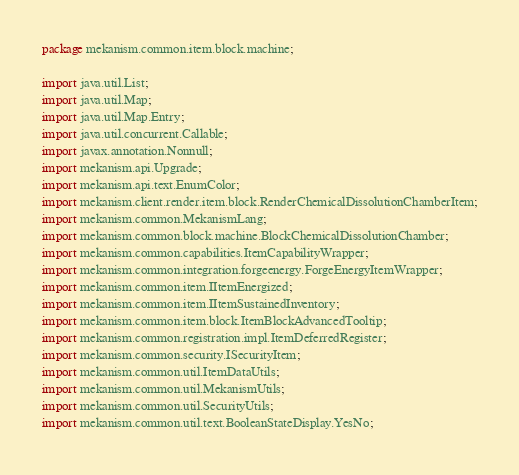<code> <loc_0><loc_0><loc_500><loc_500><_Java_>package mekanism.common.item.block.machine;

import java.util.List;
import java.util.Map;
import java.util.Map.Entry;
import java.util.concurrent.Callable;
import javax.annotation.Nonnull;
import mekanism.api.Upgrade;
import mekanism.api.text.EnumColor;
import mekanism.client.render.item.block.RenderChemicalDissolutionChamberItem;
import mekanism.common.MekanismLang;
import mekanism.common.block.machine.BlockChemicalDissolutionChamber;
import mekanism.common.capabilities.ItemCapabilityWrapper;
import mekanism.common.integration.forgeenergy.ForgeEnergyItemWrapper;
import mekanism.common.item.IItemEnergized;
import mekanism.common.item.IItemSustainedInventory;
import mekanism.common.item.block.ItemBlockAdvancedTooltip;
import mekanism.common.registration.impl.ItemDeferredRegister;
import mekanism.common.security.ISecurityItem;
import mekanism.common.util.ItemDataUtils;
import mekanism.common.util.MekanismUtils;
import mekanism.common.util.SecurityUtils;
import mekanism.common.util.text.BooleanStateDisplay.YesNo;</code> 